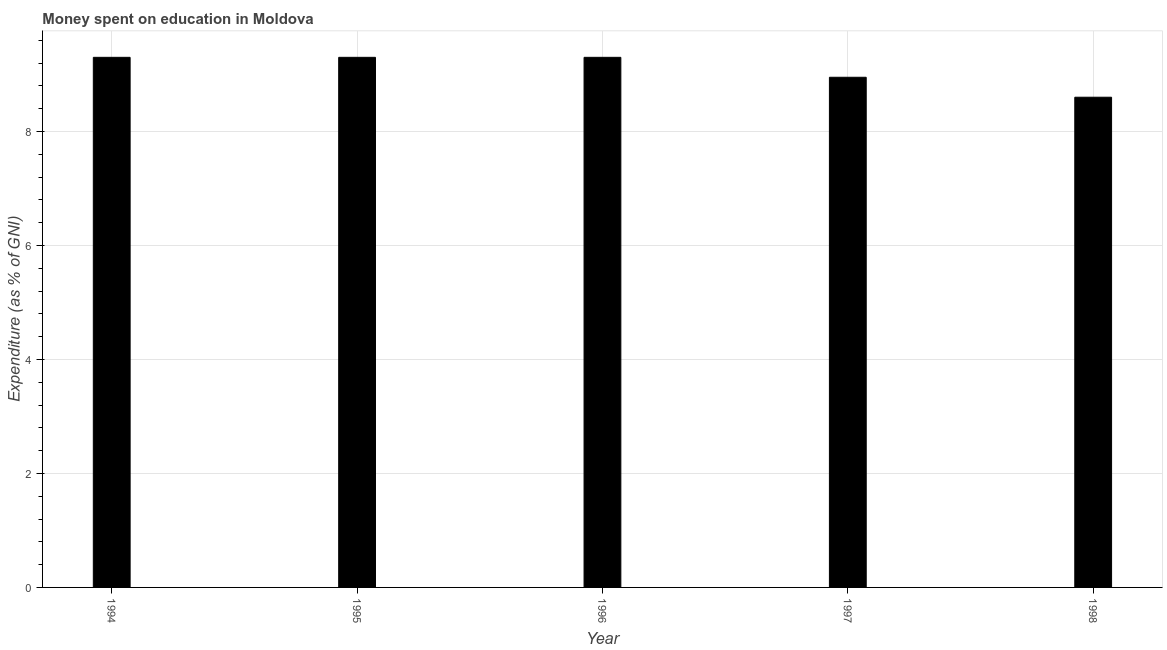Does the graph contain grids?
Give a very brief answer. Yes. What is the title of the graph?
Your answer should be compact. Money spent on education in Moldova. What is the label or title of the Y-axis?
Provide a succinct answer. Expenditure (as % of GNI). Across all years, what is the minimum expenditure on education?
Ensure brevity in your answer.  8.6. In which year was the expenditure on education maximum?
Offer a very short reply. 1994. In which year was the expenditure on education minimum?
Your answer should be compact. 1998. What is the sum of the expenditure on education?
Give a very brief answer. 45.45. What is the average expenditure on education per year?
Provide a short and direct response. 9.09. What is the ratio of the expenditure on education in 1995 to that in 1998?
Provide a succinct answer. 1.08. What is the difference between the highest and the second highest expenditure on education?
Your answer should be compact. 0. Is the sum of the expenditure on education in 1996 and 1998 greater than the maximum expenditure on education across all years?
Provide a succinct answer. Yes. In how many years, is the expenditure on education greater than the average expenditure on education taken over all years?
Provide a short and direct response. 3. What is the difference between two consecutive major ticks on the Y-axis?
Make the answer very short. 2. What is the Expenditure (as % of GNI) in 1996?
Give a very brief answer. 9.3. What is the Expenditure (as % of GNI) in 1997?
Keep it short and to the point. 8.95. What is the Expenditure (as % of GNI) of 1998?
Offer a terse response. 8.6. What is the difference between the Expenditure (as % of GNI) in 1994 and 1996?
Your response must be concise. 0. What is the difference between the Expenditure (as % of GNI) in 1995 and 1997?
Your answer should be very brief. 0.35. What is the ratio of the Expenditure (as % of GNI) in 1994 to that in 1995?
Offer a very short reply. 1. What is the ratio of the Expenditure (as % of GNI) in 1994 to that in 1997?
Provide a short and direct response. 1.04. What is the ratio of the Expenditure (as % of GNI) in 1994 to that in 1998?
Your answer should be compact. 1.08. What is the ratio of the Expenditure (as % of GNI) in 1995 to that in 1996?
Your response must be concise. 1. What is the ratio of the Expenditure (as % of GNI) in 1995 to that in 1997?
Keep it short and to the point. 1.04. What is the ratio of the Expenditure (as % of GNI) in 1995 to that in 1998?
Provide a succinct answer. 1.08. What is the ratio of the Expenditure (as % of GNI) in 1996 to that in 1997?
Provide a short and direct response. 1.04. What is the ratio of the Expenditure (as % of GNI) in 1996 to that in 1998?
Make the answer very short. 1.08. What is the ratio of the Expenditure (as % of GNI) in 1997 to that in 1998?
Your answer should be compact. 1.04. 